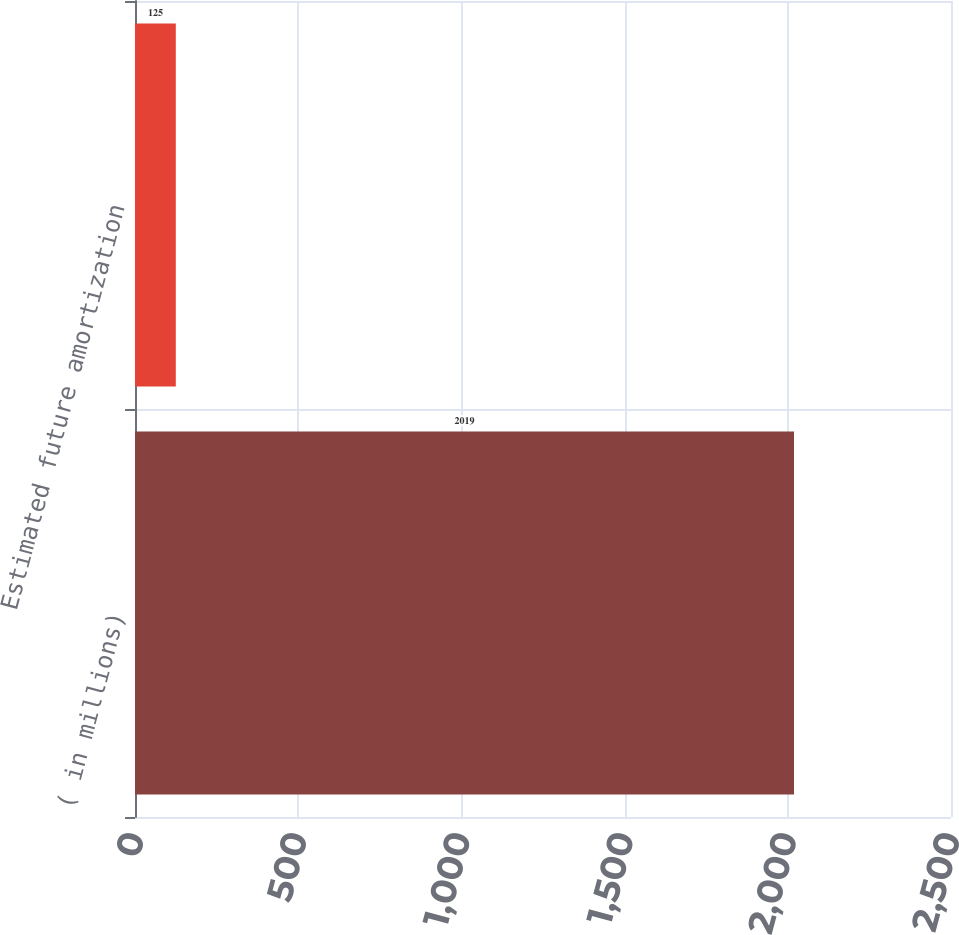<chart> <loc_0><loc_0><loc_500><loc_500><bar_chart><fcel>( in millions)<fcel>Estimated future amortization<nl><fcel>2019<fcel>125<nl></chart> 